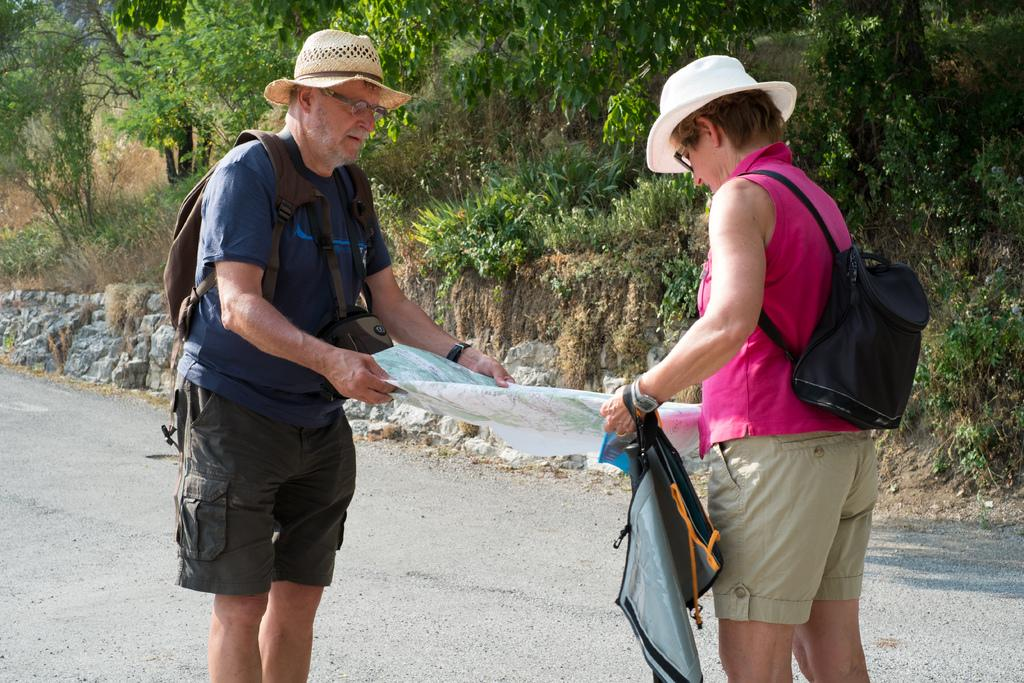How many people are in the image? There are two people in the image. What are the people doing in the image? The people are holding an object. What type of natural elements can be seen in the image? Plants, trees, and grass are visible in the image. What other objects can be seen in the image? Stones are present in the image. What direction is the body of water flowing in the image? There is no body of water present in the image. What is the taste of the object the people are holding in the image? The taste of the object cannot be determined from the image, as taste is not a visual characteristic. 